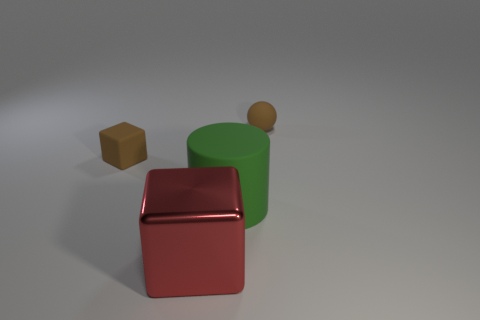What can you infer about the shapes present in this image? The image includes a variety of geometric shapes: a sphere, a cube, and a cylinder. These shapes are fundamental building blocks in both natural and man-made structures, suggesting a scene constructed to explore basic geometry. 